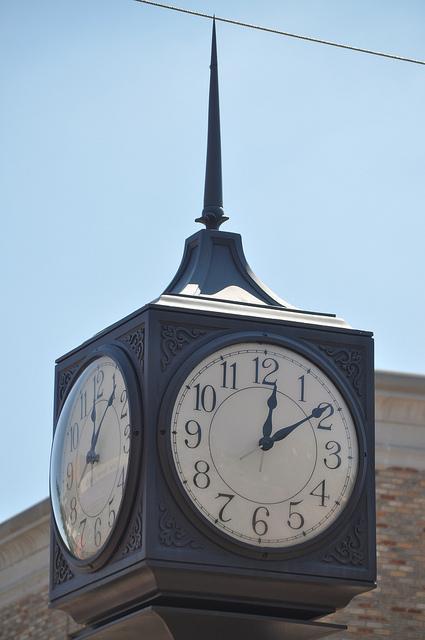How many sides to this clock?
Give a very brief answer. 4. How many clocks are there?
Give a very brief answer. 2. 